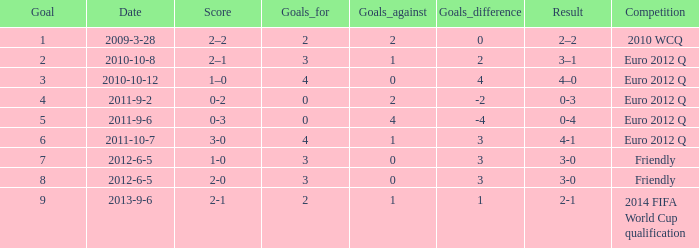How many goals when the score is 3-0 in the euro 2012 q? 1.0. Can you parse all the data within this table? {'header': ['Goal', 'Date', 'Score', 'Goals_for', 'Goals_against', 'Goals_difference', 'Result', 'Competition'], 'rows': [['1', '2009-3-28', '2–2', '2', '2', '0', '2–2', '2010 WCQ'], ['2', '2010-10-8', '2–1', '3', '1', '2', '3–1', 'Euro 2012 Q'], ['3', '2010-10-12', '1–0', '4', '0', '4', '4–0', 'Euro 2012 Q'], ['4', '2011-9-2', '0-2', '0', '2', '-2', '0-3', 'Euro 2012 Q'], ['5', '2011-9-6', '0-3', '0', '4', '-4', '0-4', 'Euro 2012 Q'], ['6', '2011-10-7', '3-0', '4', '1', '3', '4-1', 'Euro 2012 Q'], ['7', '2012-6-5', '1-0', '3', '0', '3', '3-0', 'Friendly'], ['8', '2012-6-5', '2-0', '3', '0', '3', '3-0', 'Friendly'], ['9', '2013-9-6', '2-1', '2', '1', '1', '2-1', '2014 FIFA World Cup qualification']]} 